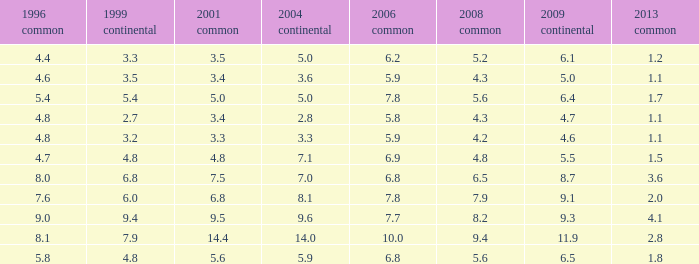What is the average value for general 2001 with more than 4.8 in 1999 European, 7.7 in 2006 general, and more than 9 in 1996 general? None. 